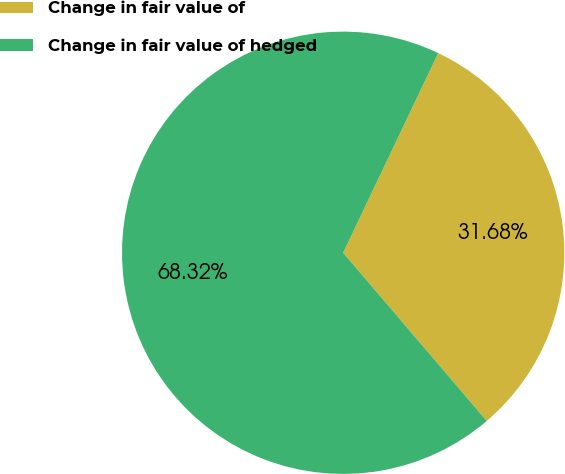<chart> <loc_0><loc_0><loc_500><loc_500><pie_chart><fcel>Change in fair value of<fcel>Change in fair value of hedged<nl><fcel>31.68%<fcel>68.32%<nl></chart> 